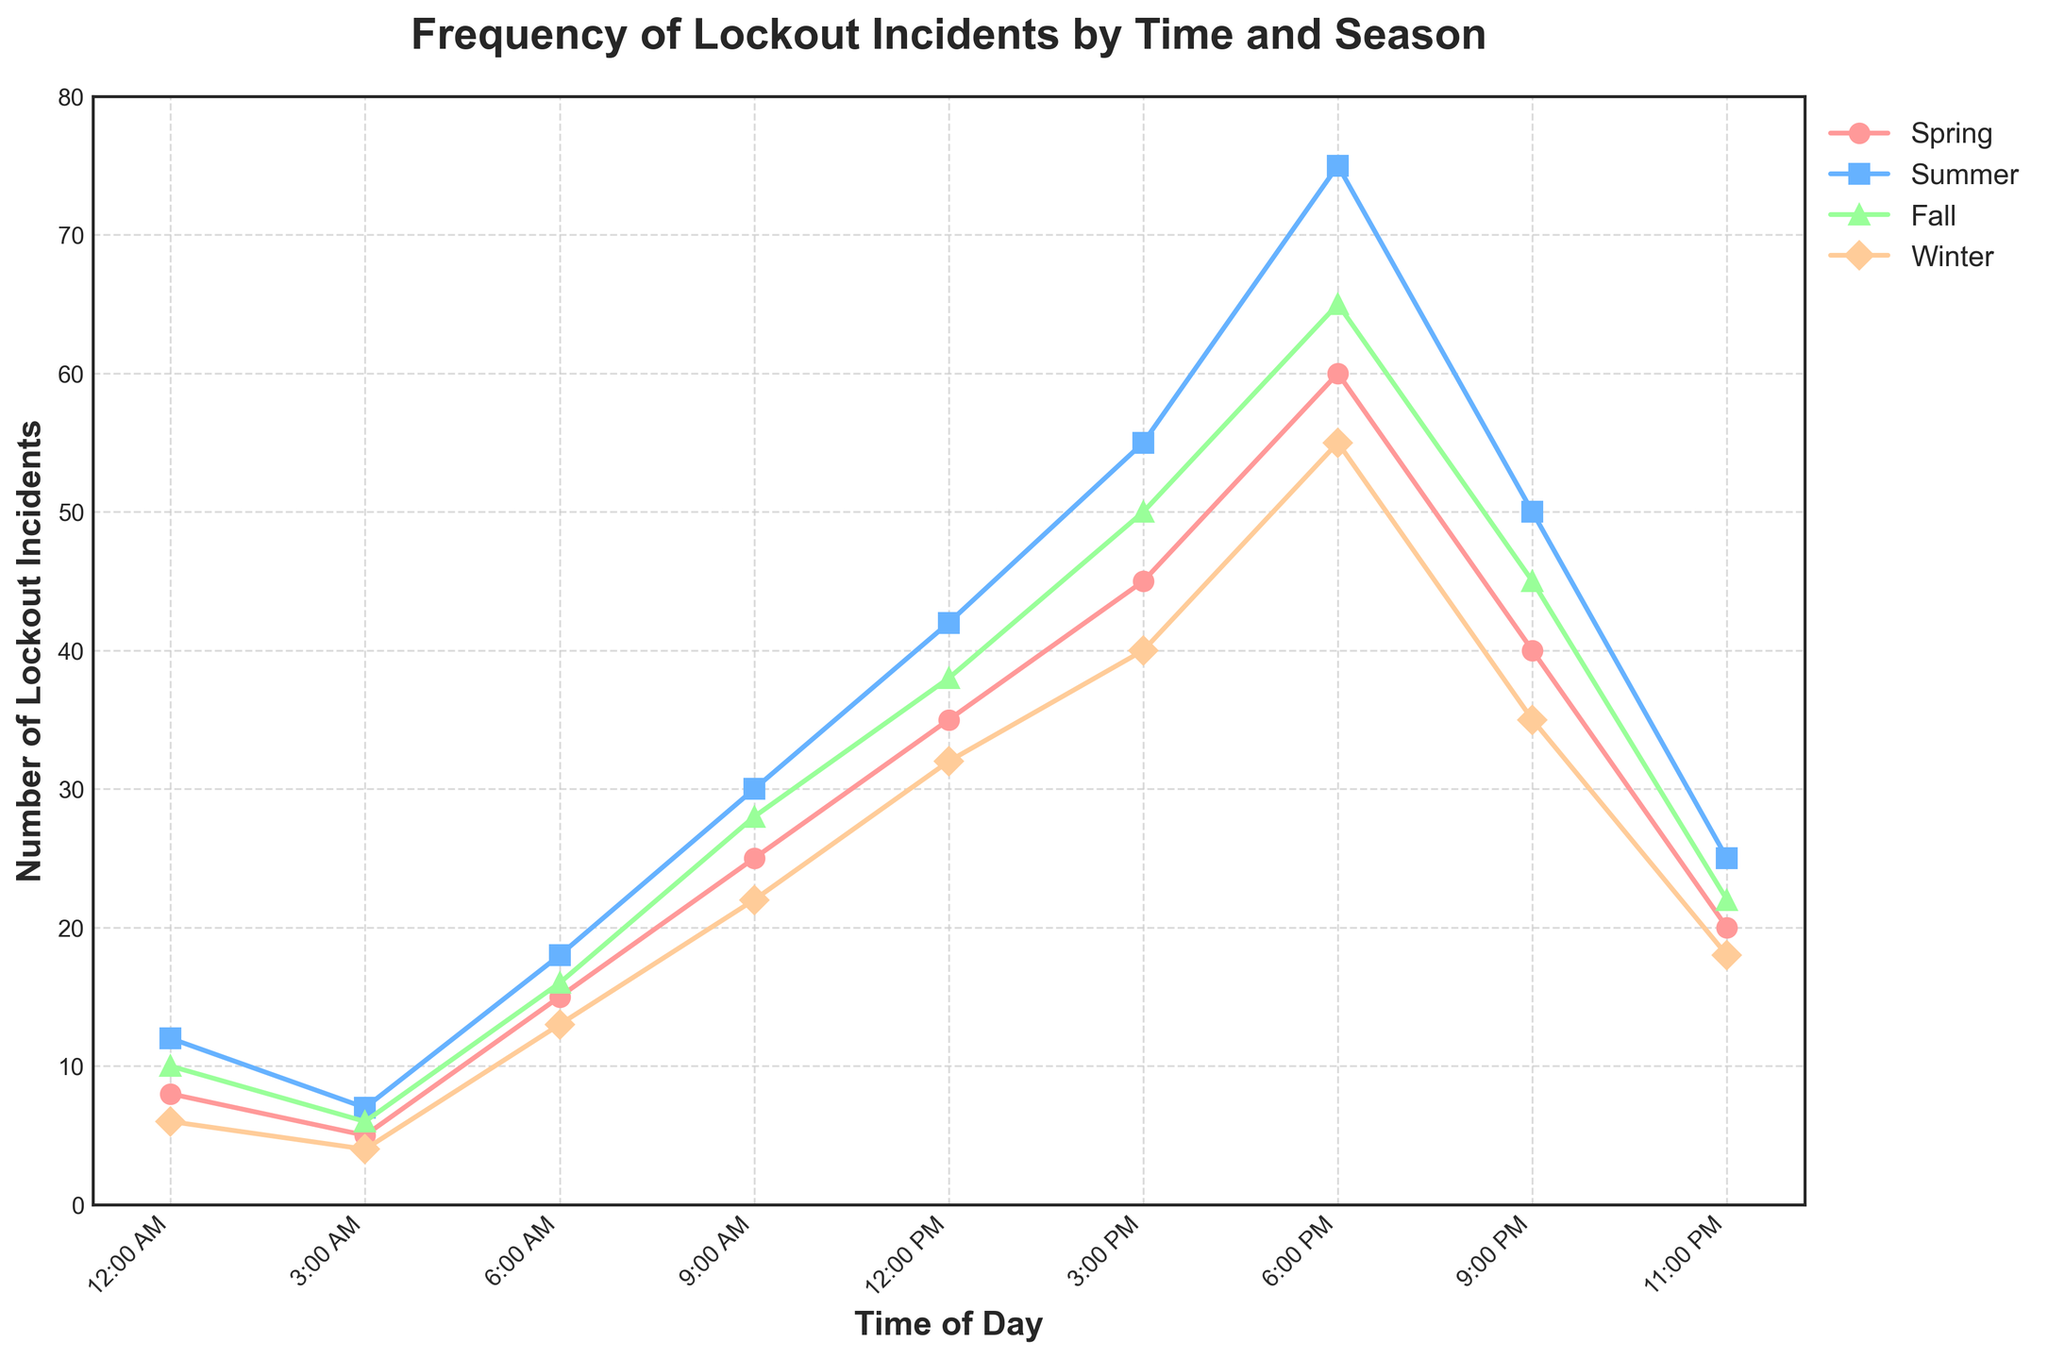Which season has the highest number of lockout incidents reported at 6:00 PM? Look at the data points for 6:00 PM across the different seasons. Summer has the highest value at that time.
Answer: Summer What is the total number of lockout incidents across all seasons at 6:00 AM? Add the number of lockout incidents at 6:00 AM for each season: 15 (Spring) + 18 (Summer) + 16 (Fall) + 13 (Winter). The total is 62.
Answer: 62 Which time of day generally has the lowest frequency of lockout incidents in Winter? Compare the values for each time of day in the Winter column. The lowest value is at 3:00 AM, which is 4 incidents.
Answer: 3:00 AM By how much do lockout incidents increase from 3:00 PM to 6:00 PM during Fall? Subtract the number of incidents at 3:00 PM from the number of incidents at 6:00 PM in Fall: 65 (6:00 PM) - 50 (3:00 PM). The increase is 15 incidents.
Answer: 15 Which season has the most variable frequency of lockout incidents throughout the day? Observe the range (difference between the highest and lowest values) for each season. Summer has the highest range from 7 to 75, indicating the most variation.
Answer: Summer At what time of day does Spring experience its peak lockout incidents? Identify the highest value in the Spring column. The peak is 60 incidents at 6:00 PM.
Answer: 6:00 PM What is the difference in the number of lockout incidents reported at 12:00 PM between Spring and Winter? Subtract the number of incidents at 12:00 PM in Winter from the number in Spring: 35 (Spring) - 32 (Winter). The difference is 3.
Answer: 3 Which season shows the closest number of lockout incidents to 20 at 11:00 PM? Compare the values at 11:00 PM across the seasons. Winter shows 18 incidents, which is closest to 20.
Answer: Winter What is the average number of reported lockout incidents at 9:00 AM across all seasons? Add the number of incidents at 9:00 AM for each season and divide by 4: (25 + 30 + 28 + 22) / 4. The average is 26.25.
Answer: 26.25 